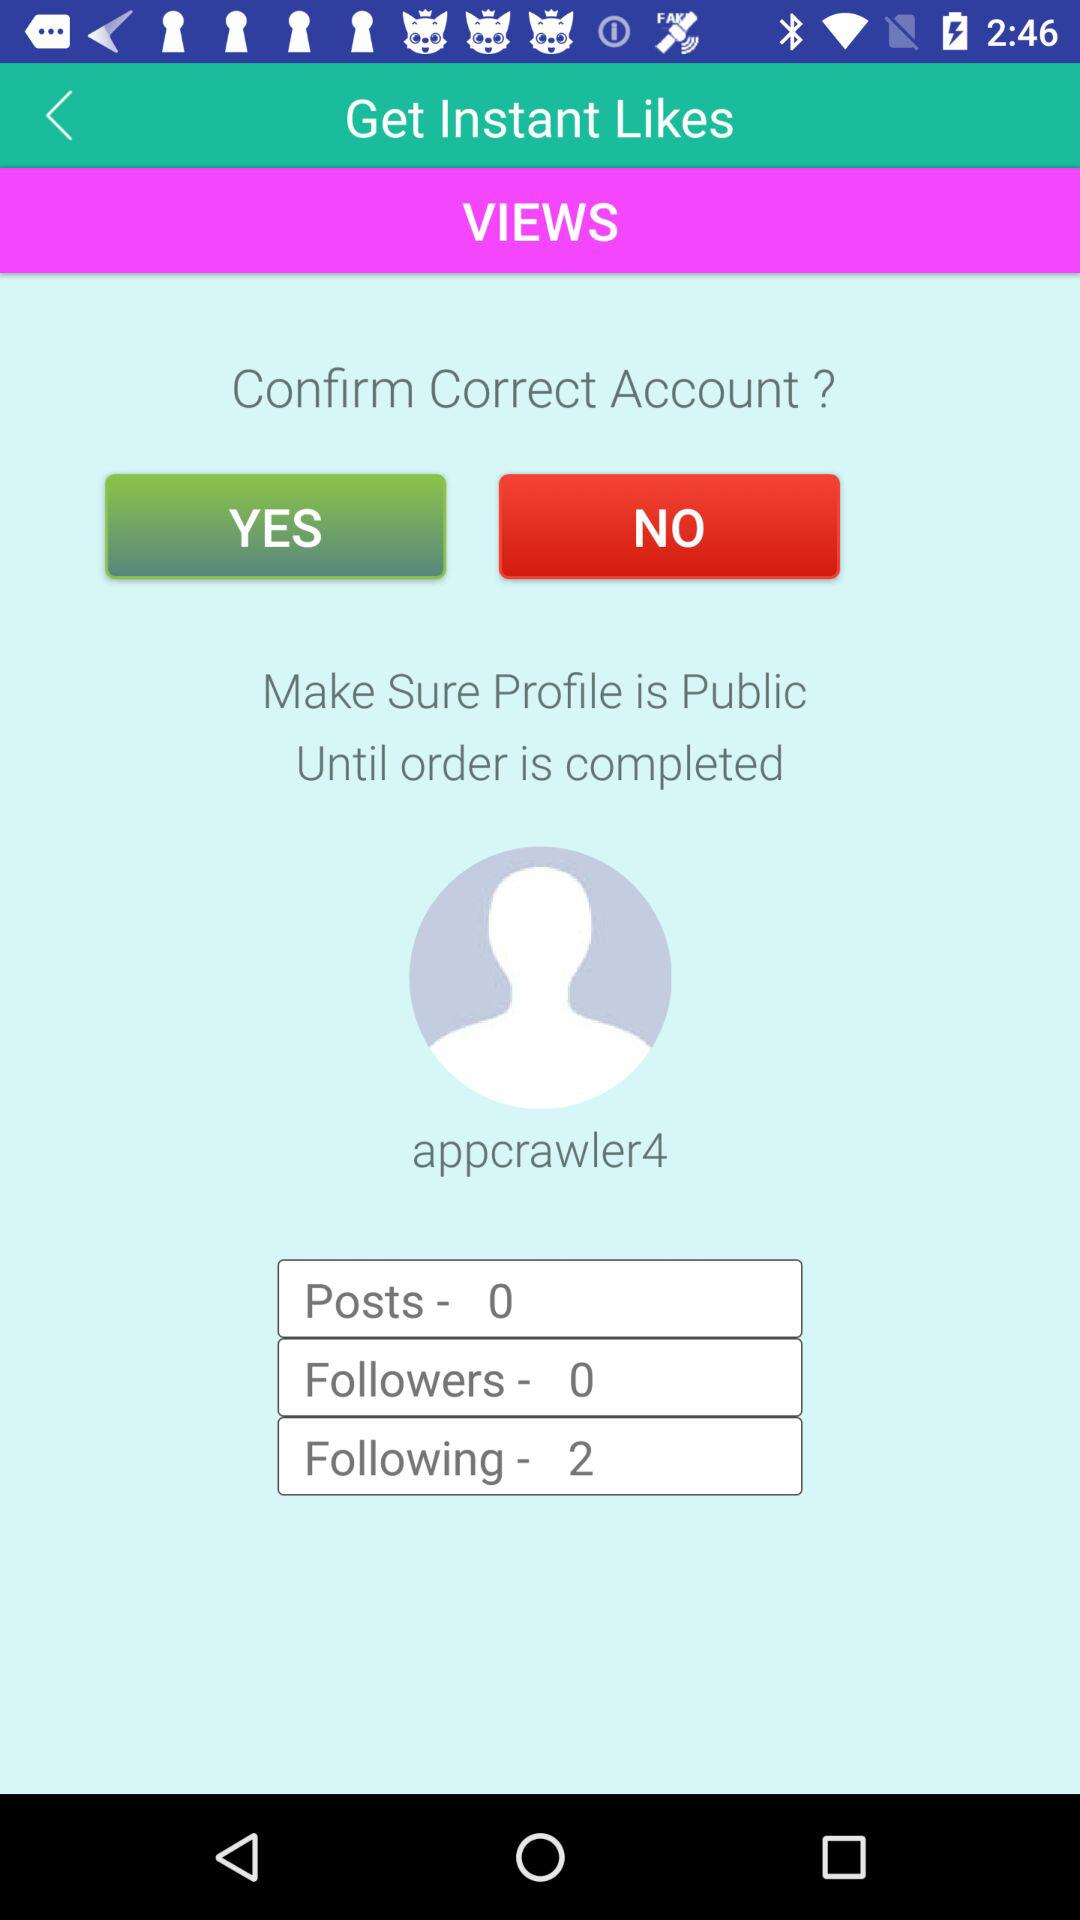How many people is "appcrawler4" following? The number of people "appcrawler4" is following is 2. 